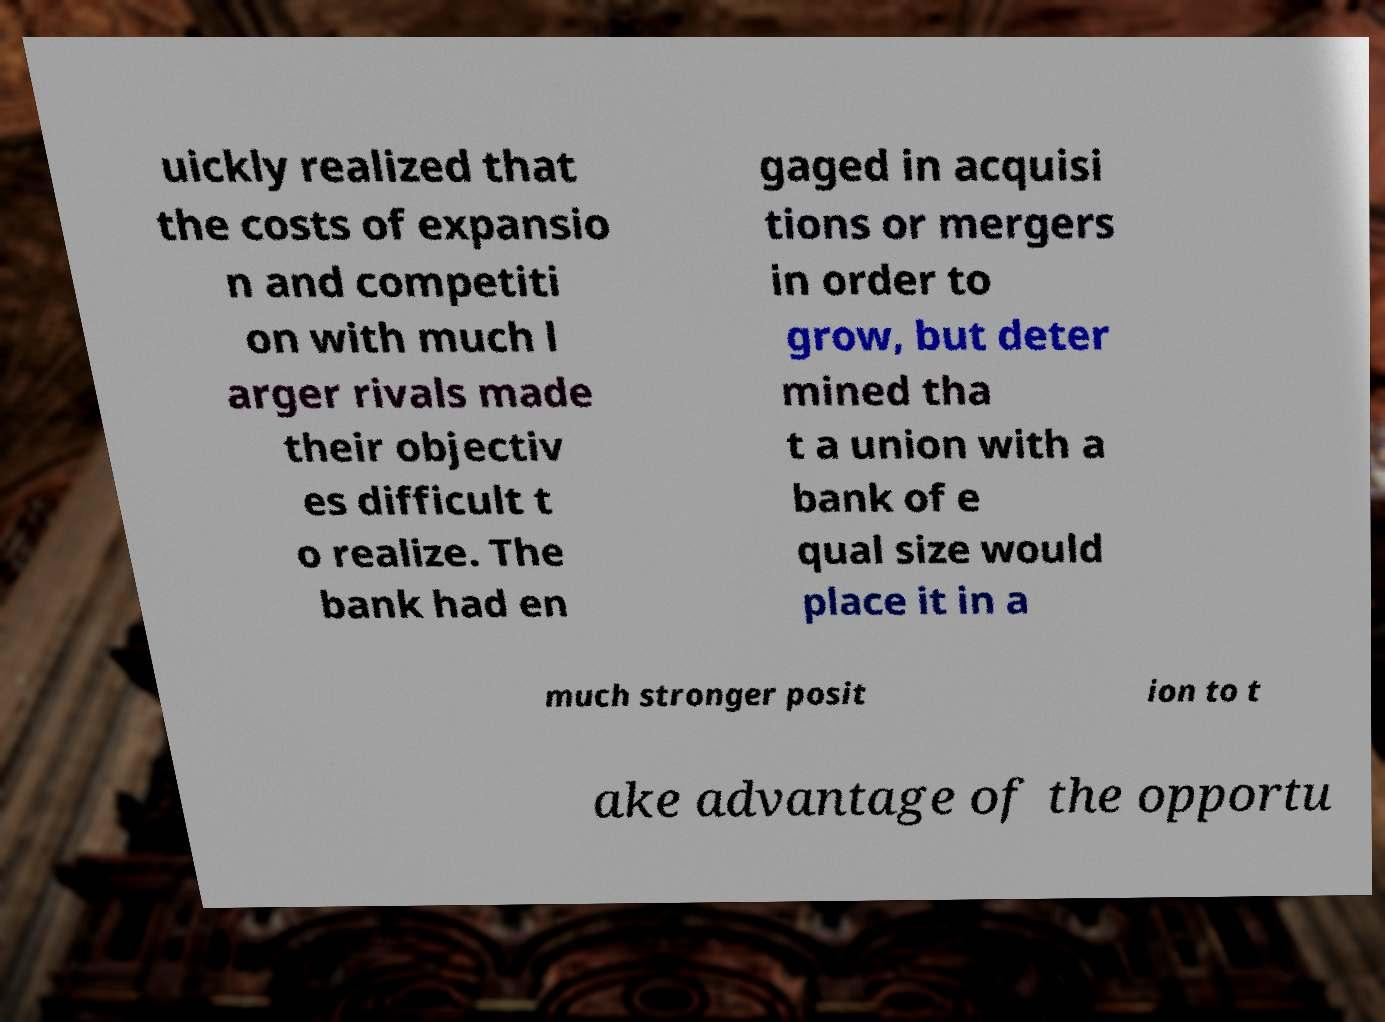For documentation purposes, I need the text within this image transcribed. Could you provide that? uickly realized that the costs of expansio n and competiti on with much l arger rivals made their objectiv es difficult t o realize. The bank had en gaged in acquisi tions or mergers in order to grow, but deter mined tha t a union with a bank of e qual size would place it in a much stronger posit ion to t ake advantage of the opportu 